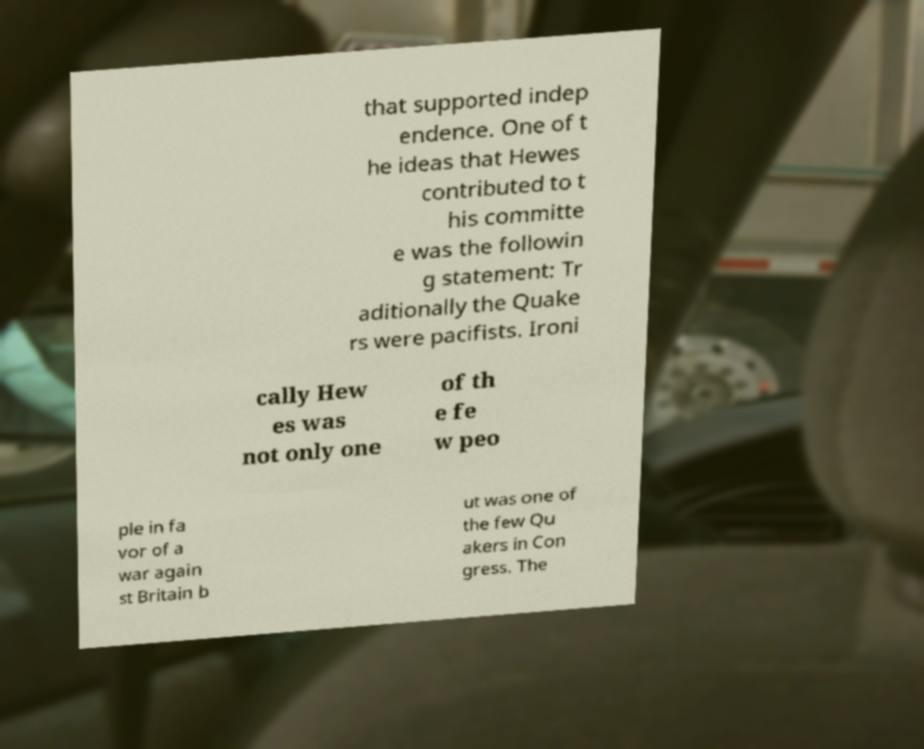For documentation purposes, I need the text within this image transcribed. Could you provide that? that supported indep endence. One of t he ideas that Hewes contributed to t his committe e was the followin g statement: Tr aditionally the Quake rs were pacifists. Ironi cally Hew es was not only one of th e fe w peo ple in fa vor of a war again st Britain b ut was one of the few Qu akers in Con gress. The 